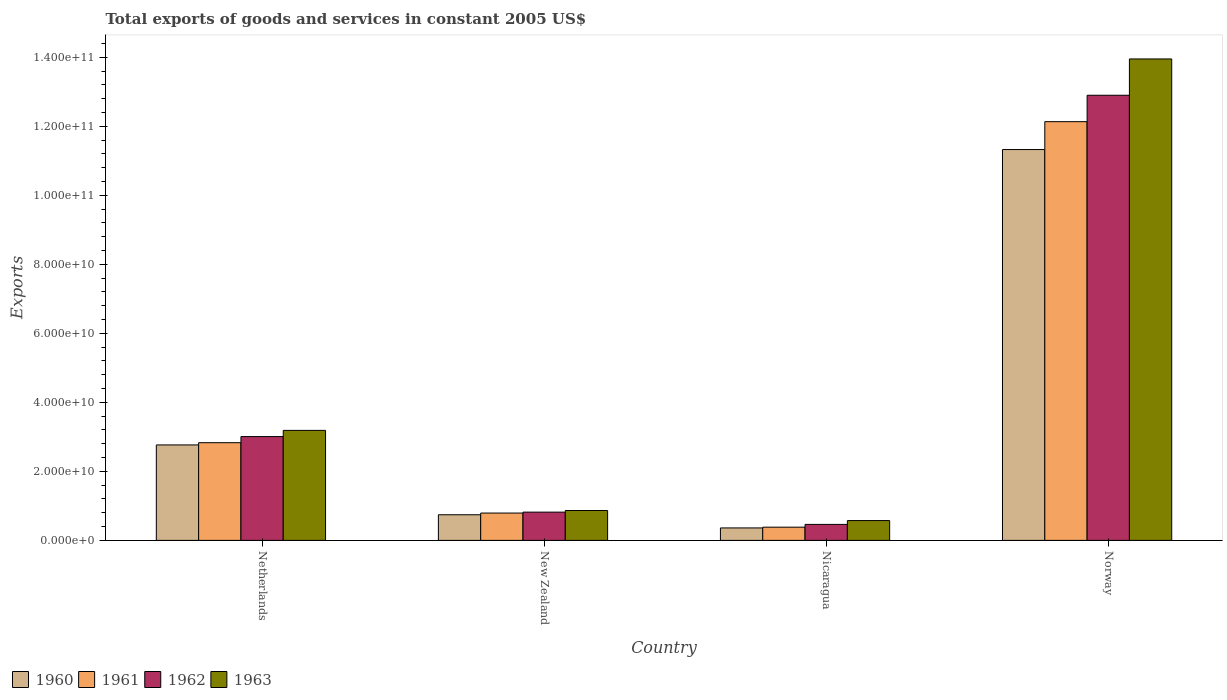Are the number of bars on each tick of the X-axis equal?
Offer a terse response. Yes. What is the label of the 2nd group of bars from the left?
Offer a terse response. New Zealand. What is the total exports of goods and services in 1963 in Norway?
Offer a very short reply. 1.40e+11. Across all countries, what is the maximum total exports of goods and services in 1963?
Make the answer very short. 1.40e+11. Across all countries, what is the minimum total exports of goods and services in 1963?
Your response must be concise. 5.74e+09. In which country was the total exports of goods and services in 1960 maximum?
Give a very brief answer. Norway. In which country was the total exports of goods and services in 1961 minimum?
Make the answer very short. Nicaragua. What is the total total exports of goods and services in 1960 in the graph?
Your response must be concise. 1.52e+11. What is the difference between the total exports of goods and services in 1961 in Nicaragua and that in Norway?
Offer a very short reply. -1.18e+11. What is the difference between the total exports of goods and services in 1960 in New Zealand and the total exports of goods and services in 1962 in Norway?
Ensure brevity in your answer.  -1.22e+11. What is the average total exports of goods and services in 1963 per country?
Keep it short and to the point. 4.64e+1. What is the difference between the total exports of goods and services of/in 1960 and total exports of goods and services of/in 1961 in Nicaragua?
Ensure brevity in your answer.  -2.16e+08. What is the ratio of the total exports of goods and services in 1963 in Netherlands to that in Nicaragua?
Your response must be concise. 5.55. Is the difference between the total exports of goods and services in 1960 in Netherlands and Nicaragua greater than the difference between the total exports of goods and services in 1961 in Netherlands and Nicaragua?
Your response must be concise. No. What is the difference between the highest and the second highest total exports of goods and services in 1960?
Keep it short and to the point. 8.56e+1. What is the difference between the highest and the lowest total exports of goods and services in 1963?
Provide a short and direct response. 1.34e+11. In how many countries, is the total exports of goods and services in 1960 greater than the average total exports of goods and services in 1960 taken over all countries?
Ensure brevity in your answer.  1. Is it the case that in every country, the sum of the total exports of goods and services in 1962 and total exports of goods and services in 1963 is greater than the sum of total exports of goods and services in 1960 and total exports of goods and services in 1961?
Your answer should be compact. No. What does the 1st bar from the left in Netherlands represents?
Offer a terse response. 1960. Is it the case that in every country, the sum of the total exports of goods and services in 1961 and total exports of goods and services in 1963 is greater than the total exports of goods and services in 1960?
Keep it short and to the point. Yes. How many bars are there?
Provide a succinct answer. 16. Does the graph contain any zero values?
Your response must be concise. No. Where does the legend appear in the graph?
Your answer should be compact. Bottom left. How many legend labels are there?
Provide a succinct answer. 4. What is the title of the graph?
Make the answer very short. Total exports of goods and services in constant 2005 US$. Does "1977" appear as one of the legend labels in the graph?
Offer a terse response. No. What is the label or title of the Y-axis?
Offer a very short reply. Exports. What is the Exports in 1960 in Netherlands?
Your answer should be very brief. 2.77e+1. What is the Exports in 1961 in Netherlands?
Give a very brief answer. 2.83e+1. What is the Exports in 1962 in Netherlands?
Your answer should be compact. 3.01e+1. What is the Exports of 1963 in Netherlands?
Offer a terse response. 3.19e+1. What is the Exports of 1960 in New Zealand?
Offer a terse response. 7.43e+09. What is the Exports in 1961 in New Zealand?
Your answer should be very brief. 7.92e+09. What is the Exports in 1962 in New Zealand?
Your answer should be compact. 8.19e+09. What is the Exports of 1963 in New Zealand?
Provide a short and direct response. 8.66e+09. What is the Exports of 1960 in Nicaragua?
Provide a succinct answer. 3.61e+09. What is the Exports of 1961 in Nicaragua?
Offer a terse response. 3.83e+09. What is the Exports of 1962 in Nicaragua?
Provide a short and direct response. 4.64e+09. What is the Exports of 1963 in Nicaragua?
Ensure brevity in your answer.  5.74e+09. What is the Exports of 1960 in Norway?
Your answer should be compact. 1.13e+11. What is the Exports of 1961 in Norway?
Your answer should be very brief. 1.21e+11. What is the Exports in 1962 in Norway?
Your response must be concise. 1.29e+11. What is the Exports in 1963 in Norway?
Provide a succinct answer. 1.40e+11. Across all countries, what is the maximum Exports of 1960?
Give a very brief answer. 1.13e+11. Across all countries, what is the maximum Exports in 1961?
Your response must be concise. 1.21e+11. Across all countries, what is the maximum Exports of 1962?
Ensure brevity in your answer.  1.29e+11. Across all countries, what is the maximum Exports in 1963?
Your answer should be compact. 1.40e+11. Across all countries, what is the minimum Exports of 1960?
Your answer should be compact. 3.61e+09. Across all countries, what is the minimum Exports in 1961?
Your response must be concise. 3.83e+09. Across all countries, what is the minimum Exports in 1962?
Ensure brevity in your answer.  4.64e+09. Across all countries, what is the minimum Exports of 1963?
Offer a very short reply. 5.74e+09. What is the total Exports in 1960 in the graph?
Your answer should be very brief. 1.52e+11. What is the total Exports in 1961 in the graph?
Your response must be concise. 1.61e+11. What is the total Exports of 1962 in the graph?
Your answer should be very brief. 1.72e+11. What is the total Exports in 1963 in the graph?
Ensure brevity in your answer.  1.86e+11. What is the difference between the Exports of 1960 in Netherlands and that in New Zealand?
Provide a short and direct response. 2.02e+1. What is the difference between the Exports of 1961 in Netherlands and that in New Zealand?
Offer a terse response. 2.04e+1. What is the difference between the Exports of 1962 in Netherlands and that in New Zealand?
Offer a very short reply. 2.19e+1. What is the difference between the Exports in 1963 in Netherlands and that in New Zealand?
Keep it short and to the point. 2.32e+1. What is the difference between the Exports in 1960 in Netherlands and that in Nicaragua?
Your response must be concise. 2.41e+1. What is the difference between the Exports in 1961 in Netherlands and that in Nicaragua?
Your answer should be very brief. 2.45e+1. What is the difference between the Exports of 1962 in Netherlands and that in Nicaragua?
Provide a succinct answer. 2.54e+1. What is the difference between the Exports of 1963 in Netherlands and that in Nicaragua?
Offer a terse response. 2.61e+1. What is the difference between the Exports in 1960 in Netherlands and that in Norway?
Provide a succinct answer. -8.56e+1. What is the difference between the Exports in 1961 in Netherlands and that in Norway?
Give a very brief answer. -9.30e+1. What is the difference between the Exports of 1962 in Netherlands and that in Norway?
Your answer should be compact. -9.89e+1. What is the difference between the Exports of 1963 in Netherlands and that in Norway?
Keep it short and to the point. -1.08e+11. What is the difference between the Exports in 1960 in New Zealand and that in Nicaragua?
Your answer should be very brief. 3.82e+09. What is the difference between the Exports in 1961 in New Zealand and that in Nicaragua?
Give a very brief answer. 4.10e+09. What is the difference between the Exports of 1962 in New Zealand and that in Nicaragua?
Your answer should be compact. 3.55e+09. What is the difference between the Exports of 1963 in New Zealand and that in Nicaragua?
Give a very brief answer. 2.92e+09. What is the difference between the Exports of 1960 in New Zealand and that in Norway?
Offer a very short reply. -1.06e+11. What is the difference between the Exports in 1961 in New Zealand and that in Norway?
Give a very brief answer. -1.13e+11. What is the difference between the Exports in 1962 in New Zealand and that in Norway?
Offer a very short reply. -1.21e+11. What is the difference between the Exports in 1963 in New Zealand and that in Norway?
Provide a short and direct response. -1.31e+11. What is the difference between the Exports in 1960 in Nicaragua and that in Norway?
Give a very brief answer. -1.10e+11. What is the difference between the Exports of 1961 in Nicaragua and that in Norway?
Offer a terse response. -1.18e+11. What is the difference between the Exports of 1962 in Nicaragua and that in Norway?
Keep it short and to the point. -1.24e+11. What is the difference between the Exports of 1963 in Nicaragua and that in Norway?
Keep it short and to the point. -1.34e+11. What is the difference between the Exports in 1960 in Netherlands and the Exports in 1961 in New Zealand?
Your response must be concise. 1.97e+1. What is the difference between the Exports in 1960 in Netherlands and the Exports in 1962 in New Zealand?
Your answer should be very brief. 1.95e+1. What is the difference between the Exports in 1960 in Netherlands and the Exports in 1963 in New Zealand?
Make the answer very short. 1.90e+1. What is the difference between the Exports in 1961 in Netherlands and the Exports in 1962 in New Zealand?
Provide a short and direct response. 2.01e+1. What is the difference between the Exports in 1961 in Netherlands and the Exports in 1963 in New Zealand?
Your answer should be very brief. 1.97e+1. What is the difference between the Exports in 1962 in Netherlands and the Exports in 1963 in New Zealand?
Offer a terse response. 2.14e+1. What is the difference between the Exports in 1960 in Netherlands and the Exports in 1961 in Nicaragua?
Give a very brief answer. 2.38e+1. What is the difference between the Exports in 1960 in Netherlands and the Exports in 1962 in Nicaragua?
Offer a terse response. 2.30e+1. What is the difference between the Exports of 1960 in Netherlands and the Exports of 1963 in Nicaragua?
Your response must be concise. 2.19e+1. What is the difference between the Exports of 1961 in Netherlands and the Exports of 1962 in Nicaragua?
Ensure brevity in your answer.  2.37e+1. What is the difference between the Exports in 1961 in Netherlands and the Exports in 1963 in Nicaragua?
Your answer should be very brief. 2.26e+1. What is the difference between the Exports in 1962 in Netherlands and the Exports in 1963 in Nicaragua?
Offer a very short reply. 2.43e+1. What is the difference between the Exports of 1960 in Netherlands and the Exports of 1961 in Norway?
Your response must be concise. -9.37e+1. What is the difference between the Exports in 1960 in Netherlands and the Exports in 1962 in Norway?
Offer a very short reply. -1.01e+11. What is the difference between the Exports of 1960 in Netherlands and the Exports of 1963 in Norway?
Keep it short and to the point. -1.12e+11. What is the difference between the Exports of 1961 in Netherlands and the Exports of 1962 in Norway?
Offer a terse response. -1.01e+11. What is the difference between the Exports in 1961 in Netherlands and the Exports in 1963 in Norway?
Offer a terse response. -1.11e+11. What is the difference between the Exports of 1962 in Netherlands and the Exports of 1963 in Norway?
Your answer should be very brief. -1.09e+11. What is the difference between the Exports of 1960 in New Zealand and the Exports of 1961 in Nicaragua?
Make the answer very short. 3.60e+09. What is the difference between the Exports of 1960 in New Zealand and the Exports of 1962 in Nicaragua?
Offer a very short reply. 2.79e+09. What is the difference between the Exports of 1960 in New Zealand and the Exports of 1963 in Nicaragua?
Make the answer very short. 1.68e+09. What is the difference between the Exports of 1961 in New Zealand and the Exports of 1962 in Nicaragua?
Keep it short and to the point. 3.29e+09. What is the difference between the Exports of 1961 in New Zealand and the Exports of 1963 in Nicaragua?
Provide a succinct answer. 2.18e+09. What is the difference between the Exports of 1962 in New Zealand and the Exports of 1963 in Nicaragua?
Provide a short and direct response. 2.45e+09. What is the difference between the Exports of 1960 in New Zealand and the Exports of 1961 in Norway?
Ensure brevity in your answer.  -1.14e+11. What is the difference between the Exports of 1960 in New Zealand and the Exports of 1962 in Norway?
Ensure brevity in your answer.  -1.22e+11. What is the difference between the Exports of 1960 in New Zealand and the Exports of 1963 in Norway?
Offer a very short reply. -1.32e+11. What is the difference between the Exports in 1961 in New Zealand and the Exports in 1962 in Norway?
Provide a short and direct response. -1.21e+11. What is the difference between the Exports in 1961 in New Zealand and the Exports in 1963 in Norway?
Give a very brief answer. -1.32e+11. What is the difference between the Exports in 1962 in New Zealand and the Exports in 1963 in Norway?
Offer a terse response. -1.31e+11. What is the difference between the Exports of 1960 in Nicaragua and the Exports of 1961 in Norway?
Ensure brevity in your answer.  -1.18e+11. What is the difference between the Exports in 1960 in Nicaragua and the Exports in 1962 in Norway?
Offer a very short reply. -1.25e+11. What is the difference between the Exports of 1960 in Nicaragua and the Exports of 1963 in Norway?
Ensure brevity in your answer.  -1.36e+11. What is the difference between the Exports of 1961 in Nicaragua and the Exports of 1962 in Norway?
Keep it short and to the point. -1.25e+11. What is the difference between the Exports of 1961 in Nicaragua and the Exports of 1963 in Norway?
Provide a short and direct response. -1.36e+11. What is the difference between the Exports of 1962 in Nicaragua and the Exports of 1963 in Norway?
Offer a terse response. -1.35e+11. What is the average Exports in 1960 per country?
Your answer should be compact. 3.80e+1. What is the average Exports of 1961 per country?
Provide a short and direct response. 4.03e+1. What is the average Exports of 1962 per country?
Keep it short and to the point. 4.30e+1. What is the average Exports of 1963 per country?
Your response must be concise. 4.64e+1. What is the difference between the Exports in 1960 and Exports in 1961 in Netherlands?
Offer a terse response. -6.49e+08. What is the difference between the Exports in 1960 and Exports in 1962 in Netherlands?
Provide a succinct answer. -2.42e+09. What is the difference between the Exports of 1960 and Exports of 1963 in Netherlands?
Offer a very short reply. -4.21e+09. What is the difference between the Exports in 1961 and Exports in 1962 in Netherlands?
Keep it short and to the point. -1.77e+09. What is the difference between the Exports of 1961 and Exports of 1963 in Netherlands?
Your answer should be compact. -3.57e+09. What is the difference between the Exports in 1962 and Exports in 1963 in Netherlands?
Offer a very short reply. -1.80e+09. What is the difference between the Exports in 1960 and Exports in 1961 in New Zealand?
Your response must be concise. -4.96e+08. What is the difference between the Exports of 1960 and Exports of 1962 in New Zealand?
Offer a terse response. -7.63e+08. What is the difference between the Exports in 1960 and Exports in 1963 in New Zealand?
Provide a short and direct response. -1.23e+09. What is the difference between the Exports in 1961 and Exports in 1962 in New Zealand?
Your answer should be compact. -2.67e+08. What is the difference between the Exports of 1961 and Exports of 1963 in New Zealand?
Your answer should be compact. -7.36e+08. What is the difference between the Exports in 1962 and Exports in 1963 in New Zealand?
Your answer should be very brief. -4.69e+08. What is the difference between the Exports of 1960 and Exports of 1961 in Nicaragua?
Your answer should be very brief. -2.16e+08. What is the difference between the Exports in 1960 and Exports in 1962 in Nicaragua?
Provide a short and direct response. -1.02e+09. What is the difference between the Exports in 1960 and Exports in 1963 in Nicaragua?
Offer a terse response. -2.13e+09. What is the difference between the Exports in 1961 and Exports in 1962 in Nicaragua?
Your answer should be very brief. -8.09e+08. What is the difference between the Exports in 1961 and Exports in 1963 in Nicaragua?
Provide a short and direct response. -1.92e+09. What is the difference between the Exports of 1962 and Exports of 1963 in Nicaragua?
Your answer should be very brief. -1.11e+09. What is the difference between the Exports of 1960 and Exports of 1961 in Norway?
Your answer should be compact. -8.08e+09. What is the difference between the Exports in 1960 and Exports in 1962 in Norway?
Keep it short and to the point. -1.57e+1. What is the difference between the Exports in 1960 and Exports in 1963 in Norway?
Provide a short and direct response. -2.63e+1. What is the difference between the Exports in 1961 and Exports in 1962 in Norway?
Your answer should be very brief. -7.65e+09. What is the difference between the Exports of 1961 and Exports of 1963 in Norway?
Offer a very short reply. -1.82e+1. What is the difference between the Exports of 1962 and Exports of 1963 in Norway?
Your answer should be very brief. -1.05e+1. What is the ratio of the Exports of 1960 in Netherlands to that in New Zealand?
Ensure brevity in your answer.  3.72. What is the ratio of the Exports in 1961 in Netherlands to that in New Zealand?
Your answer should be very brief. 3.57. What is the ratio of the Exports in 1962 in Netherlands to that in New Zealand?
Make the answer very short. 3.67. What is the ratio of the Exports of 1963 in Netherlands to that in New Zealand?
Your answer should be compact. 3.68. What is the ratio of the Exports of 1960 in Netherlands to that in Nicaragua?
Provide a short and direct response. 7.66. What is the ratio of the Exports of 1961 in Netherlands to that in Nicaragua?
Keep it short and to the point. 7.4. What is the ratio of the Exports in 1962 in Netherlands to that in Nicaragua?
Keep it short and to the point. 6.49. What is the ratio of the Exports of 1963 in Netherlands to that in Nicaragua?
Make the answer very short. 5.55. What is the ratio of the Exports in 1960 in Netherlands to that in Norway?
Offer a terse response. 0.24. What is the ratio of the Exports of 1961 in Netherlands to that in Norway?
Provide a succinct answer. 0.23. What is the ratio of the Exports of 1962 in Netherlands to that in Norway?
Make the answer very short. 0.23. What is the ratio of the Exports in 1963 in Netherlands to that in Norway?
Ensure brevity in your answer.  0.23. What is the ratio of the Exports of 1960 in New Zealand to that in Nicaragua?
Your answer should be very brief. 2.06. What is the ratio of the Exports in 1961 in New Zealand to that in Nicaragua?
Provide a succinct answer. 2.07. What is the ratio of the Exports of 1962 in New Zealand to that in Nicaragua?
Make the answer very short. 1.77. What is the ratio of the Exports in 1963 in New Zealand to that in Nicaragua?
Your answer should be compact. 1.51. What is the ratio of the Exports of 1960 in New Zealand to that in Norway?
Provide a short and direct response. 0.07. What is the ratio of the Exports in 1961 in New Zealand to that in Norway?
Keep it short and to the point. 0.07. What is the ratio of the Exports of 1962 in New Zealand to that in Norway?
Your answer should be very brief. 0.06. What is the ratio of the Exports of 1963 in New Zealand to that in Norway?
Provide a short and direct response. 0.06. What is the ratio of the Exports of 1960 in Nicaragua to that in Norway?
Your answer should be compact. 0.03. What is the ratio of the Exports of 1961 in Nicaragua to that in Norway?
Offer a very short reply. 0.03. What is the ratio of the Exports of 1962 in Nicaragua to that in Norway?
Provide a short and direct response. 0.04. What is the ratio of the Exports in 1963 in Nicaragua to that in Norway?
Offer a very short reply. 0.04. What is the difference between the highest and the second highest Exports of 1960?
Make the answer very short. 8.56e+1. What is the difference between the highest and the second highest Exports in 1961?
Provide a succinct answer. 9.30e+1. What is the difference between the highest and the second highest Exports of 1962?
Ensure brevity in your answer.  9.89e+1. What is the difference between the highest and the second highest Exports of 1963?
Your answer should be compact. 1.08e+11. What is the difference between the highest and the lowest Exports in 1960?
Your answer should be compact. 1.10e+11. What is the difference between the highest and the lowest Exports in 1961?
Provide a succinct answer. 1.18e+11. What is the difference between the highest and the lowest Exports of 1962?
Offer a very short reply. 1.24e+11. What is the difference between the highest and the lowest Exports of 1963?
Ensure brevity in your answer.  1.34e+11. 